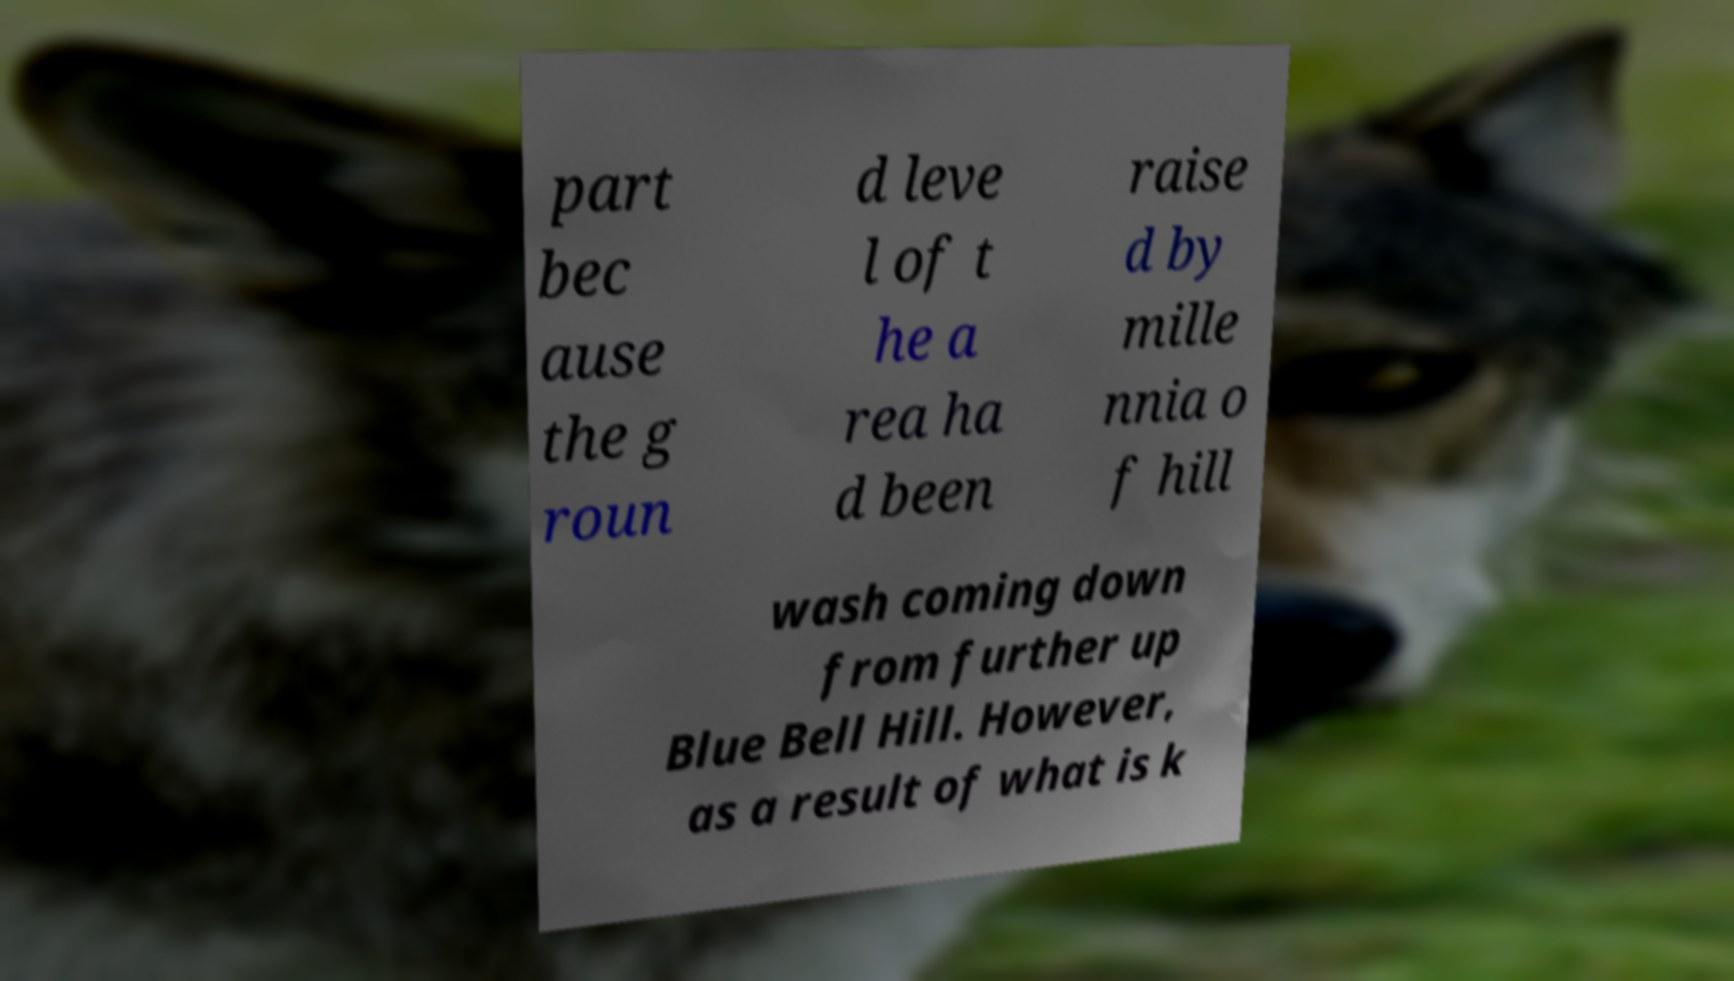There's text embedded in this image that I need extracted. Can you transcribe it verbatim? part bec ause the g roun d leve l of t he a rea ha d been raise d by mille nnia o f hill wash coming down from further up Blue Bell Hill. However, as a result of what is k 